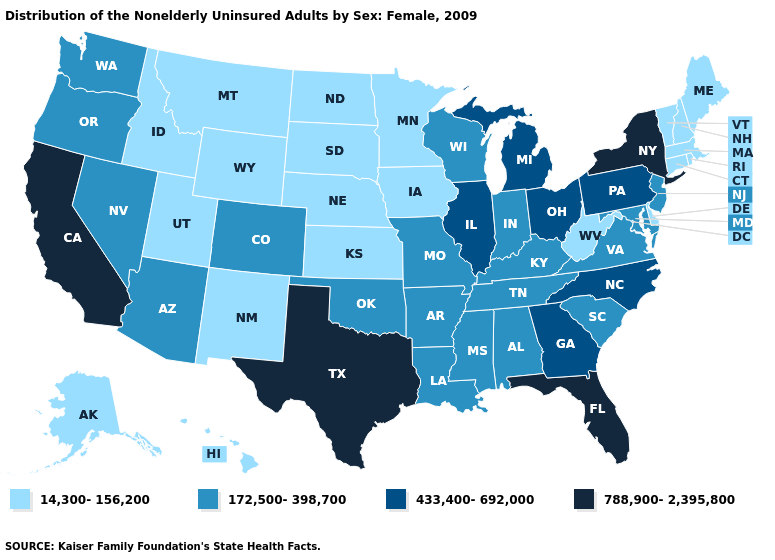Name the states that have a value in the range 172,500-398,700?
Keep it brief. Alabama, Arizona, Arkansas, Colorado, Indiana, Kentucky, Louisiana, Maryland, Mississippi, Missouri, Nevada, New Jersey, Oklahoma, Oregon, South Carolina, Tennessee, Virginia, Washington, Wisconsin. How many symbols are there in the legend?
Answer briefly. 4. Name the states that have a value in the range 14,300-156,200?
Give a very brief answer. Alaska, Connecticut, Delaware, Hawaii, Idaho, Iowa, Kansas, Maine, Massachusetts, Minnesota, Montana, Nebraska, New Hampshire, New Mexico, North Dakota, Rhode Island, South Dakota, Utah, Vermont, West Virginia, Wyoming. Name the states that have a value in the range 14,300-156,200?
Write a very short answer. Alaska, Connecticut, Delaware, Hawaii, Idaho, Iowa, Kansas, Maine, Massachusetts, Minnesota, Montana, Nebraska, New Hampshire, New Mexico, North Dakota, Rhode Island, South Dakota, Utah, Vermont, West Virginia, Wyoming. Name the states that have a value in the range 788,900-2,395,800?
Concise answer only. California, Florida, New York, Texas. Does the map have missing data?
Answer briefly. No. Does South Dakota have the lowest value in the MidWest?
Concise answer only. Yes. Does Nebraska have the highest value in the MidWest?
Concise answer only. No. Does the first symbol in the legend represent the smallest category?
Keep it brief. Yes. Which states have the highest value in the USA?
Keep it brief. California, Florida, New York, Texas. Name the states that have a value in the range 172,500-398,700?
Be succinct. Alabama, Arizona, Arkansas, Colorado, Indiana, Kentucky, Louisiana, Maryland, Mississippi, Missouri, Nevada, New Jersey, Oklahoma, Oregon, South Carolina, Tennessee, Virginia, Washington, Wisconsin. Among the states that border Louisiana , which have the lowest value?
Quick response, please. Arkansas, Mississippi. Does Oklahoma have a lower value than Alaska?
Be succinct. No. Does Vermont have the lowest value in the Northeast?
Be succinct. Yes. Which states have the lowest value in the West?
Give a very brief answer. Alaska, Hawaii, Idaho, Montana, New Mexico, Utah, Wyoming. 